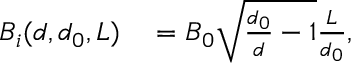<formula> <loc_0><loc_0><loc_500><loc_500>\begin{array} { r l } { B _ { i } ( d , d _ { 0 } , L ) } & = B _ { 0 } \sqrt { \frac { d _ { 0 } } { d } - 1 } \frac { L } { d _ { 0 } } , } \end{array}</formula> 